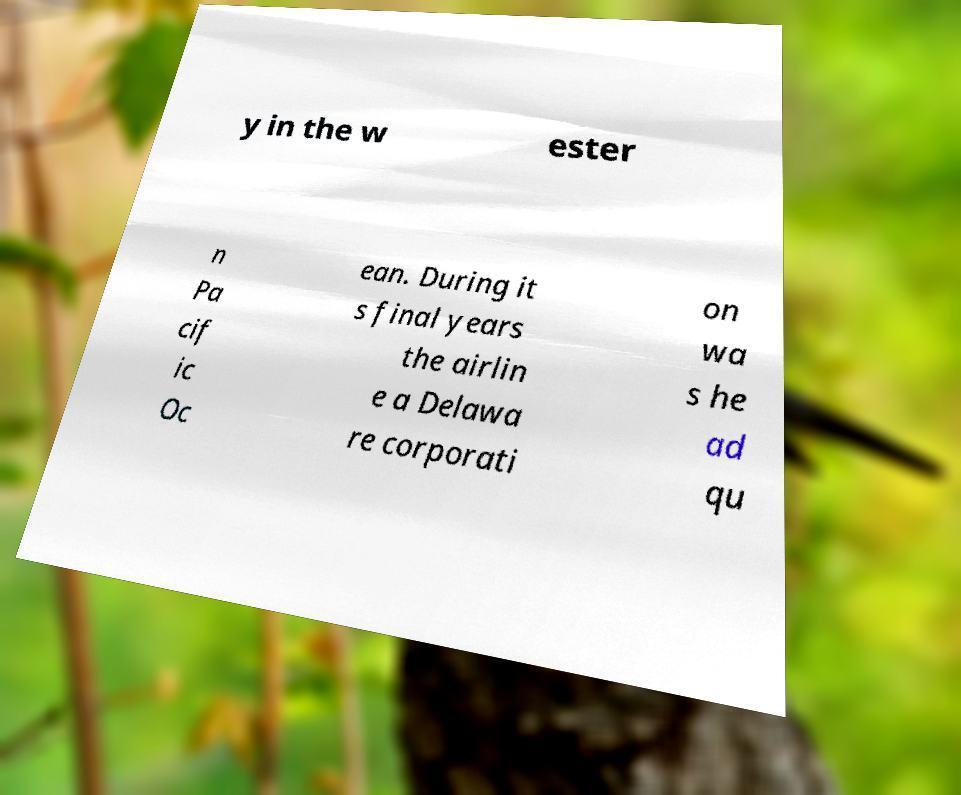Could you extract and type out the text from this image? y in the w ester n Pa cif ic Oc ean. During it s final years the airlin e a Delawa re corporati on wa s he ad qu 